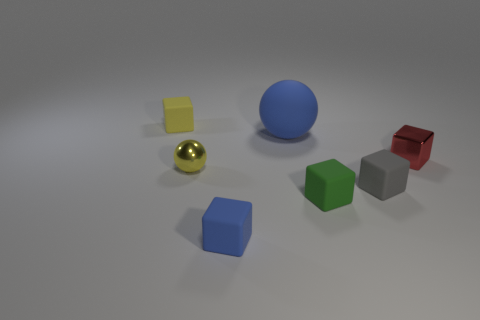Subtract all small green cubes. How many cubes are left? 4 Subtract all blue cubes. How many cubes are left? 4 Subtract 2 cubes. How many cubes are left? 3 Subtract all purple blocks. Subtract all cyan spheres. How many blocks are left? 5 Add 2 large yellow matte cylinders. How many objects exist? 9 Subtract all blocks. How many objects are left? 2 Subtract 0 cyan spheres. How many objects are left? 7 Subtract all yellow spheres. Subtract all shiny blocks. How many objects are left? 5 Add 1 gray things. How many gray things are left? 2 Add 5 red shiny objects. How many red shiny objects exist? 6 